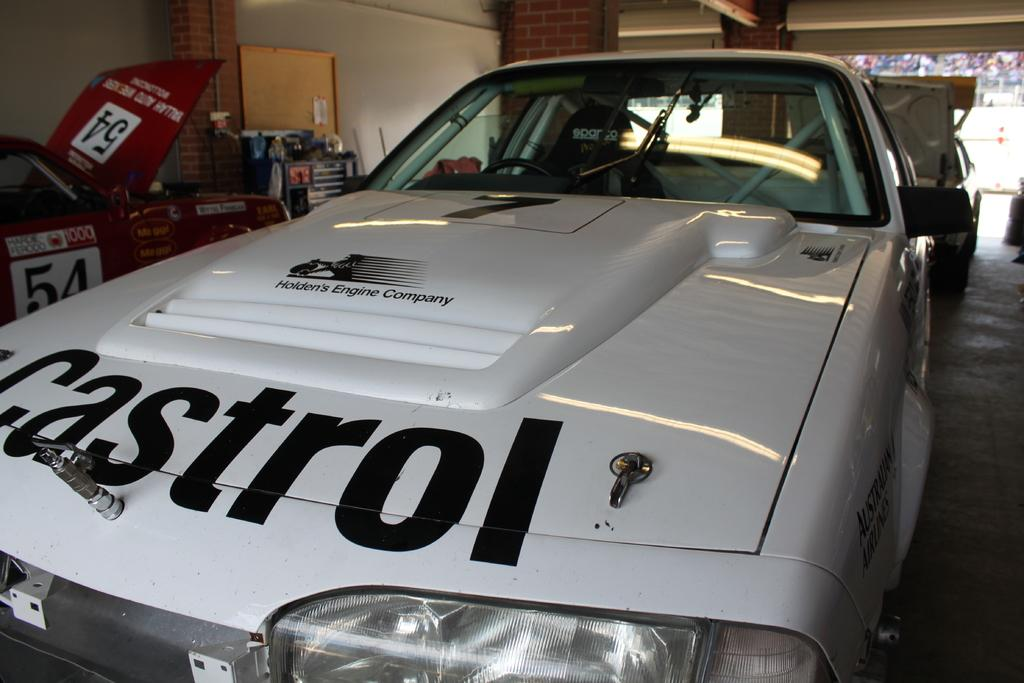What type of vehicles are in the image? There are racing cars in the image. What can be seen on the left side of the image? There is a stand on the left side of the image. What is visible in the background of the image? There is a wall in the background of the image. Can you see a writer wearing a crown in the image? There is no writer or crown present in the image. Is there a ghost visible in the image? There is no ghost present in the image. 